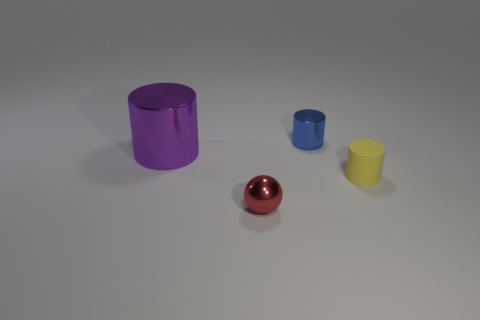Subtract all large cylinders. How many cylinders are left? 2 Subtract 1 cylinders. How many cylinders are left? 2 Add 3 small brown rubber spheres. How many objects exist? 7 Subtract all purple cylinders. How many cylinders are left? 2 Add 2 gray rubber blocks. How many gray rubber blocks exist? 2 Subtract 0 red cylinders. How many objects are left? 4 Subtract all balls. How many objects are left? 3 Subtract all blue cylinders. Subtract all yellow balls. How many cylinders are left? 2 Subtract all blue metallic objects. Subtract all brown matte spheres. How many objects are left? 3 Add 2 tiny yellow rubber objects. How many tiny yellow rubber objects are left? 3 